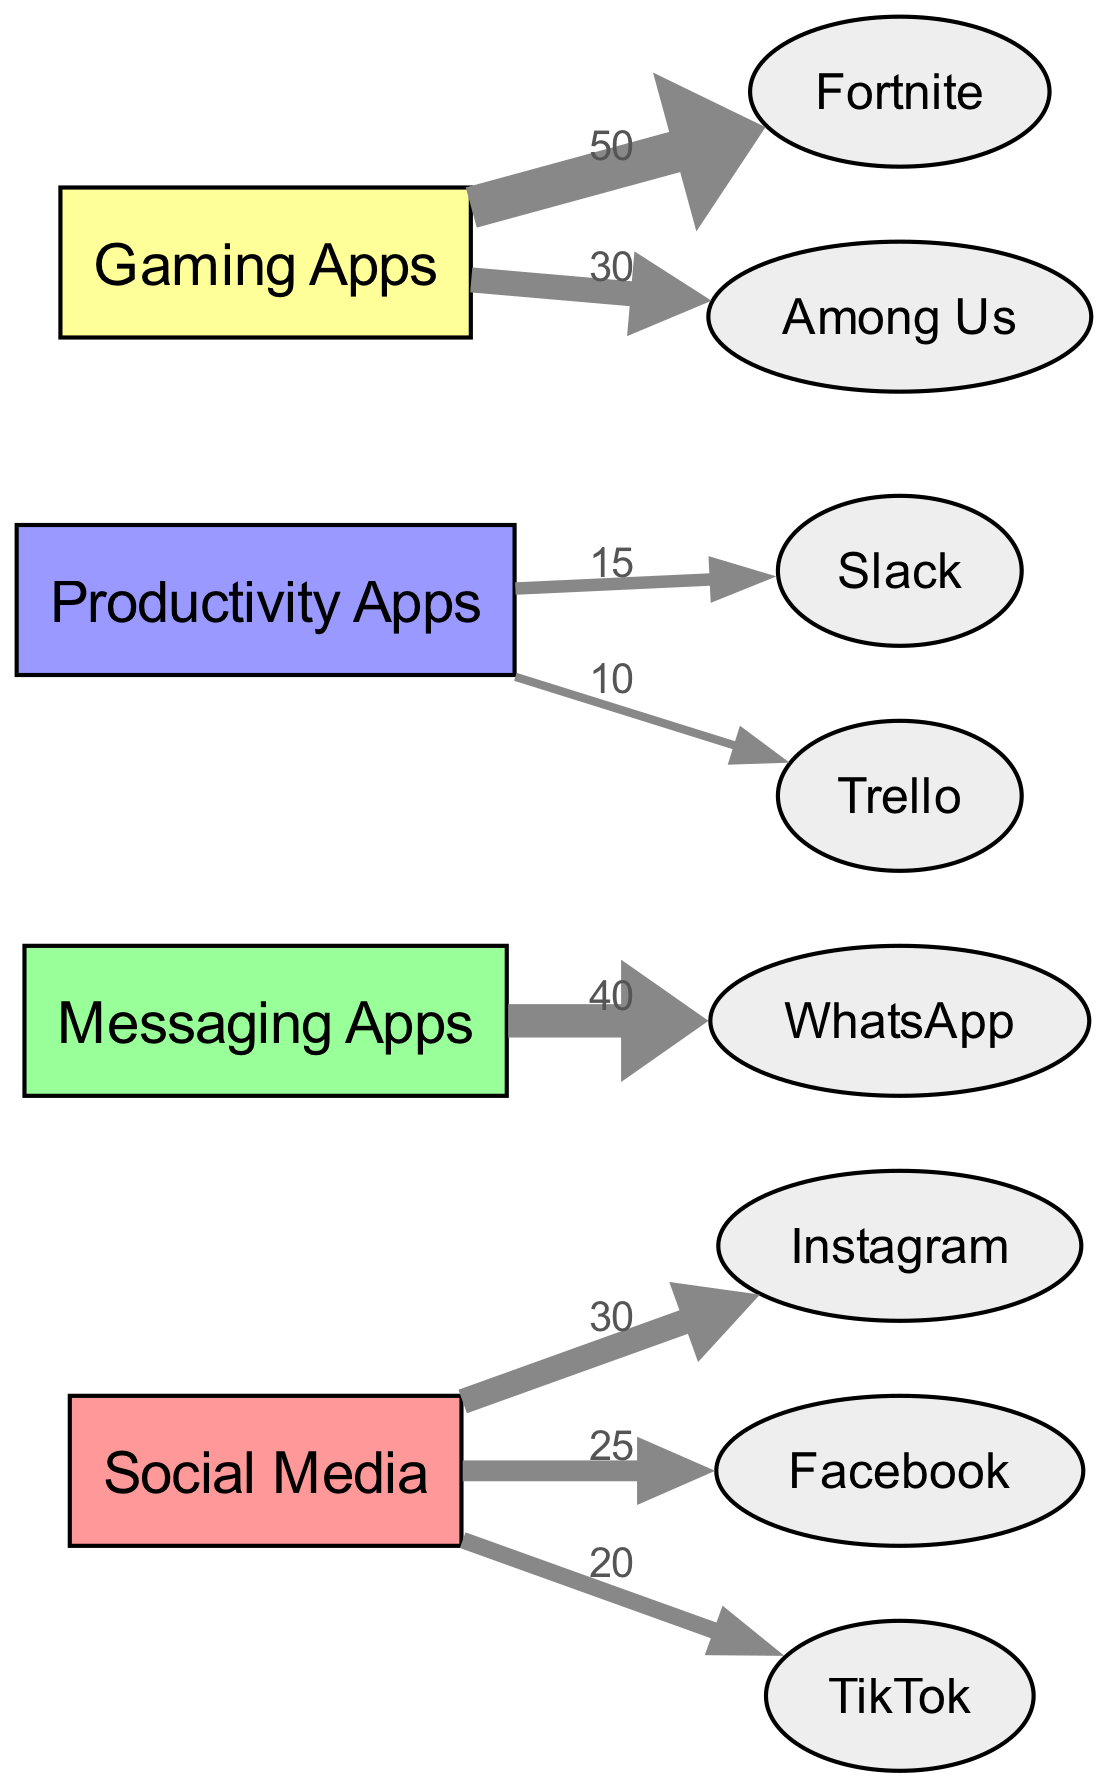What is the total usage value for Gaming Apps? By adding the values of Fortnite (50) and Among Us (30) from the Gaming Apps category, we find the total usage value: 50 + 30 = 80.
Answer: 80 Which app has the highest usage in the Social Media category? The values for Social Media apps are Instagram (30), Facebook (25), and TikTok (20). The highest value is for Instagram at 30.
Answer: Instagram How many different app categories are represented in the diagram? The categories present in the diagram are: Social Media, Messaging Apps, Productivity Apps, and Gaming Apps. Therefore, there are 4 categories.
Answer: 4 What is the usage value for WhatsApp in Messaging Apps? The value for WhatsApp, as indicated in the diagram, is 40.
Answer: 40 Which category has the lowest total usage value? First, we calculate the total for each category: Social Media (30 + 25 + 20 = 75), Messaging Apps (40), Productivity Apps (15 + 10 = 25), and Gaming Apps (50 + 30 = 80). The lowest total is for Productivity Apps at 25.
Answer: Productivity Apps How many edges connect the Social Media category to its apps? The diagram shows three edges connecting Social Media to the apps: Instagram, Facebook, and TikTok. Therefore, there are 3 edges.
Answer: 3 What is the combined total usage for Productivity Apps? The individual usages for Productivity Apps are Slack (15) and Trello (10). Adding these together: 15 + 10 = 25.
Answer: 25 Which app has the same usage value as the total for Messaging Apps? The total usage for Messaging Apps is 40 (the value for WhatsApp). The only app with this value is WhatsApp itself since it's in the same category.
Answer: WhatsApp What is the value associated with TikTok under Social Media? The value for TikTok in the Social Media category is 20, as shown in the diagram.
Answer: 20 